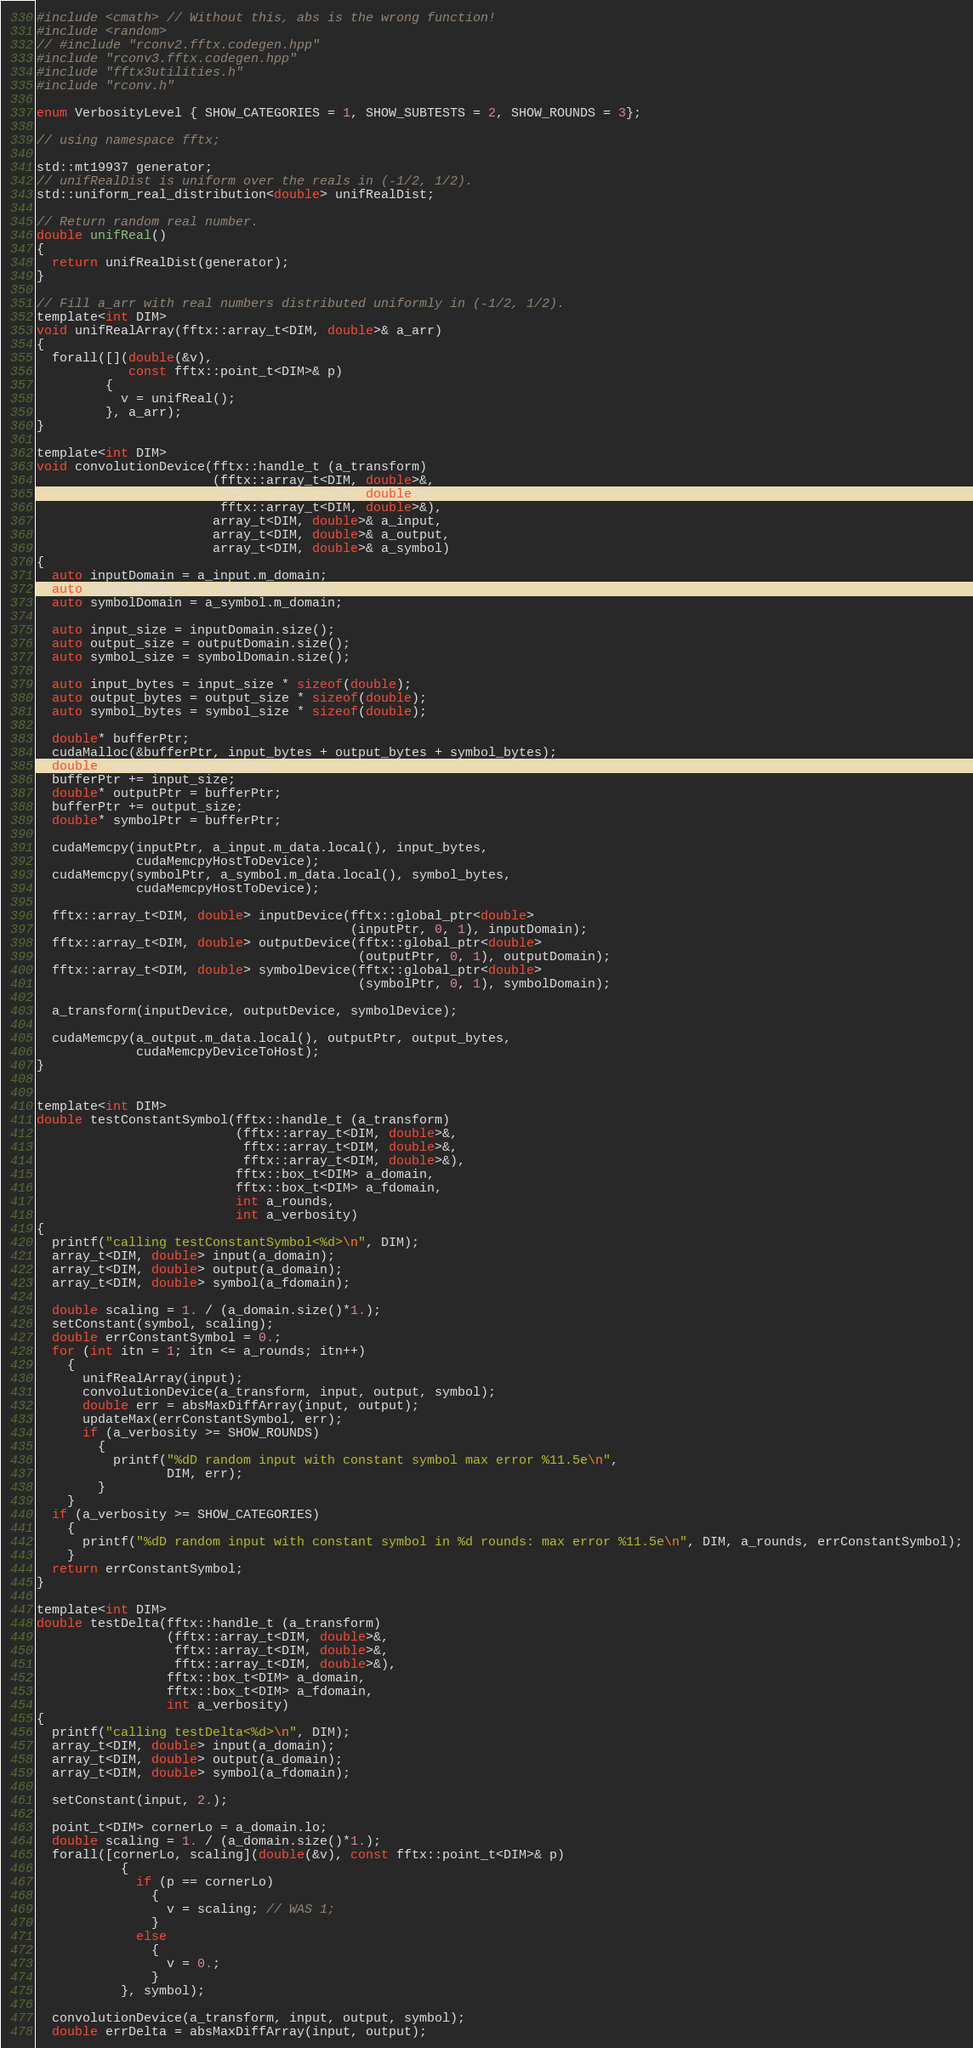<code> <loc_0><loc_0><loc_500><loc_500><_Cuda_>#include <cmath> // Without this, abs is the wrong function!
#include <random>
// #include "rconv2.fftx.codegen.hpp"
#include "rconv3.fftx.codegen.hpp"
#include "fftx3utilities.h"
#include "rconv.h"

enum VerbosityLevel { SHOW_CATEGORIES = 1, SHOW_SUBTESTS = 2, SHOW_ROUNDS = 3};
  
// using namespace fftx;

std::mt19937 generator;
// unifRealDist is uniform over the reals in (-1/2, 1/2).
std::uniform_real_distribution<double> unifRealDist;

// Return random real number.
double unifReal()
{
  return unifRealDist(generator);
}

// Fill a_arr with real numbers distributed uniformly in (-1/2, 1/2).
template<int DIM>
void unifRealArray(fftx::array_t<DIM, double>& a_arr)
{
  forall([](double(&v),
            const fftx::point_t<DIM>& p)
         {
           v = unifReal();
         }, a_arr);
}

template<int DIM>
void convolutionDevice(fftx::handle_t (a_transform)
                       (fftx::array_t<DIM, double>&,
                        fftx::array_t<DIM, double>&,
                        fftx::array_t<DIM, double>&),
                       array_t<DIM, double>& a_input,
                       array_t<DIM, double>& a_output,
                       array_t<DIM, double>& a_symbol)
{
  auto inputDomain = a_input.m_domain;
  auto outputDomain = a_output.m_domain;
  auto symbolDomain = a_symbol.m_domain;
  
  auto input_size = inputDomain.size();
  auto output_size = outputDomain.size();
  auto symbol_size = symbolDomain.size();
  
  auto input_bytes = input_size * sizeof(double);
  auto output_bytes = output_size * sizeof(double);
  auto symbol_bytes = symbol_size * sizeof(double);
  
  double* bufferPtr;
  cudaMalloc(&bufferPtr, input_bytes + output_bytes + symbol_bytes);
  double* inputPtr = bufferPtr;
  bufferPtr += input_size;
  double* outputPtr = bufferPtr;
  bufferPtr += output_size;
  double* symbolPtr = bufferPtr;
  
  cudaMemcpy(inputPtr, a_input.m_data.local(), input_bytes,
             cudaMemcpyHostToDevice);
  cudaMemcpy(symbolPtr, a_symbol.m_data.local(), symbol_bytes,
             cudaMemcpyHostToDevice);
  
  fftx::array_t<DIM, double> inputDevice(fftx::global_ptr<double>
                                         (inputPtr, 0, 1), inputDomain);
  fftx::array_t<DIM, double> outputDevice(fftx::global_ptr<double>
                                          (outputPtr, 0, 1), outputDomain);
  fftx::array_t<DIM, double> symbolDevice(fftx::global_ptr<double>
                                          (symbolPtr, 0, 1), symbolDomain);

  a_transform(inputDevice, outputDevice, symbolDevice);

  cudaMemcpy(a_output.m_data.local(), outputPtr, output_bytes,
             cudaMemcpyDeviceToHost);
}


template<int DIM>
double testConstantSymbol(fftx::handle_t (a_transform)
                          (fftx::array_t<DIM, double>&,
                           fftx::array_t<DIM, double>&,
                           fftx::array_t<DIM, double>&),
                          fftx::box_t<DIM> a_domain,
                          fftx::box_t<DIM> a_fdomain,
                          int a_rounds,
                          int a_verbosity)
{
  printf("calling testConstantSymbol<%d>\n", DIM);
  array_t<DIM, double> input(a_domain);
  array_t<DIM, double> output(a_domain);
  array_t<DIM, double> symbol(a_fdomain);

  double scaling = 1. / (a_domain.size()*1.);
  setConstant(symbol, scaling);
  double errConstantSymbol = 0.;
  for (int itn = 1; itn <= a_rounds; itn++)
    {
      unifRealArray(input);
      convolutionDevice(a_transform, input, output, symbol);
      double err = absMaxDiffArray(input, output);
      updateMax(errConstantSymbol, err);
      if (a_verbosity >= SHOW_ROUNDS)
        {
          printf("%dD random input with constant symbol max error %11.5e\n",
                 DIM, err);
        }
    }
  if (a_verbosity >= SHOW_CATEGORIES)
    {
      printf("%dD random input with constant symbol in %d rounds: max error %11.5e\n", DIM, a_rounds, errConstantSymbol);
    }
  return errConstantSymbol;
}

template<int DIM>
double testDelta(fftx::handle_t (a_transform)
                 (fftx::array_t<DIM, double>&,
                  fftx::array_t<DIM, double>&,
                  fftx::array_t<DIM, double>&),
                 fftx::box_t<DIM> a_domain,
                 fftx::box_t<DIM> a_fdomain,
                 int a_verbosity)
{
  printf("calling testDelta<%d>\n", DIM);
  array_t<DIM, double> input(a_domain);
  array_t<DIM, double> output(a_domain);
  array_t<DIM, double> symbol(a_fdomain);

  setConstant(input, 2.);

  point_t<DIM> cornerLo = a_domain.lo;
  double scaling = 1. / (a_domain.size()*1.);
  forall([cornerLo, scaling](double(&v), const fftx::point_t<DIM>& p)
           {
             if (p == cornerLo)
               {
                 v = scaling; // WAS 1;
               }
             else
               {
                 v = 0.;
               }
           }, symbol);

  convolutionDevice(a_transform, input, output, symbol);
  double errDelta = absMaxDiffArray(input, output);</code> 